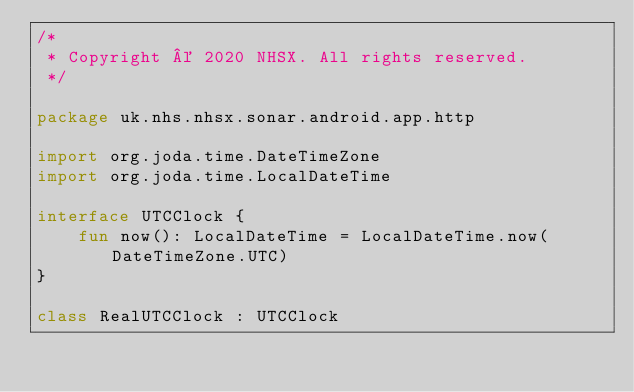Convert code to text. <code><loc_0><loc_0><loc_500><loc_500><_Kotlin_>/*
 * Copyright © 2020 NHSX. All rights reserved.
 */

package uk.nhs.nhsx.sonar.android.app.http

import org.joda.time.DateTimeZone
import org.joda.time.LocalDateTime

interface UTCClock {
    fun now(): LocalDateTime = LocalDateTime.now(DateTimeZone.UTC)
}

class RealUTCClock : UTCClock
</code> 